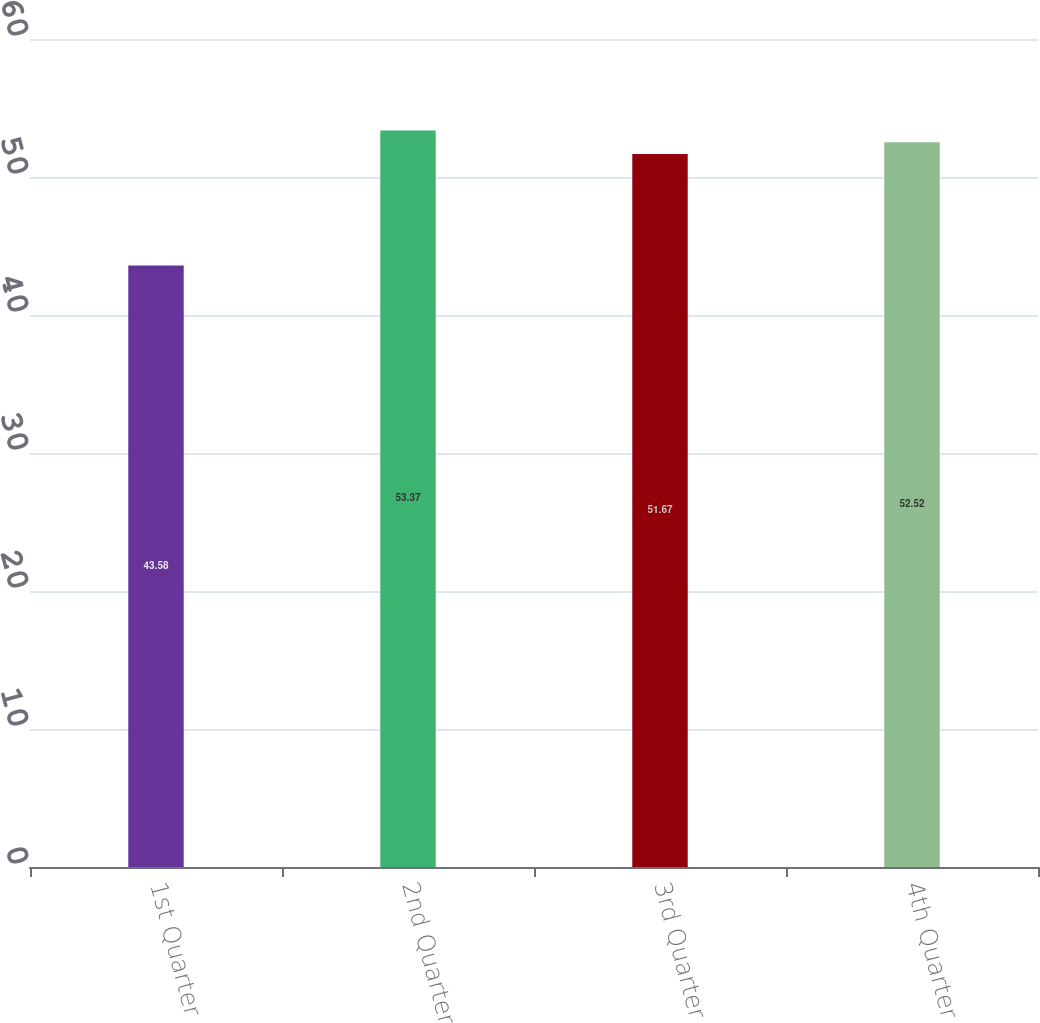Convert chart to OTSL. <chart><loc_0><loc_0><loc_500><loc_500><bar_chart><fcel>1st Quarter<fcel>2nd Quarter<fcel>3rd Quarter<fcel>4th Quarter<nl><fcel>43.58<fcel>53.37<fcel>51.67<fcel>52.52<nl></chart> 